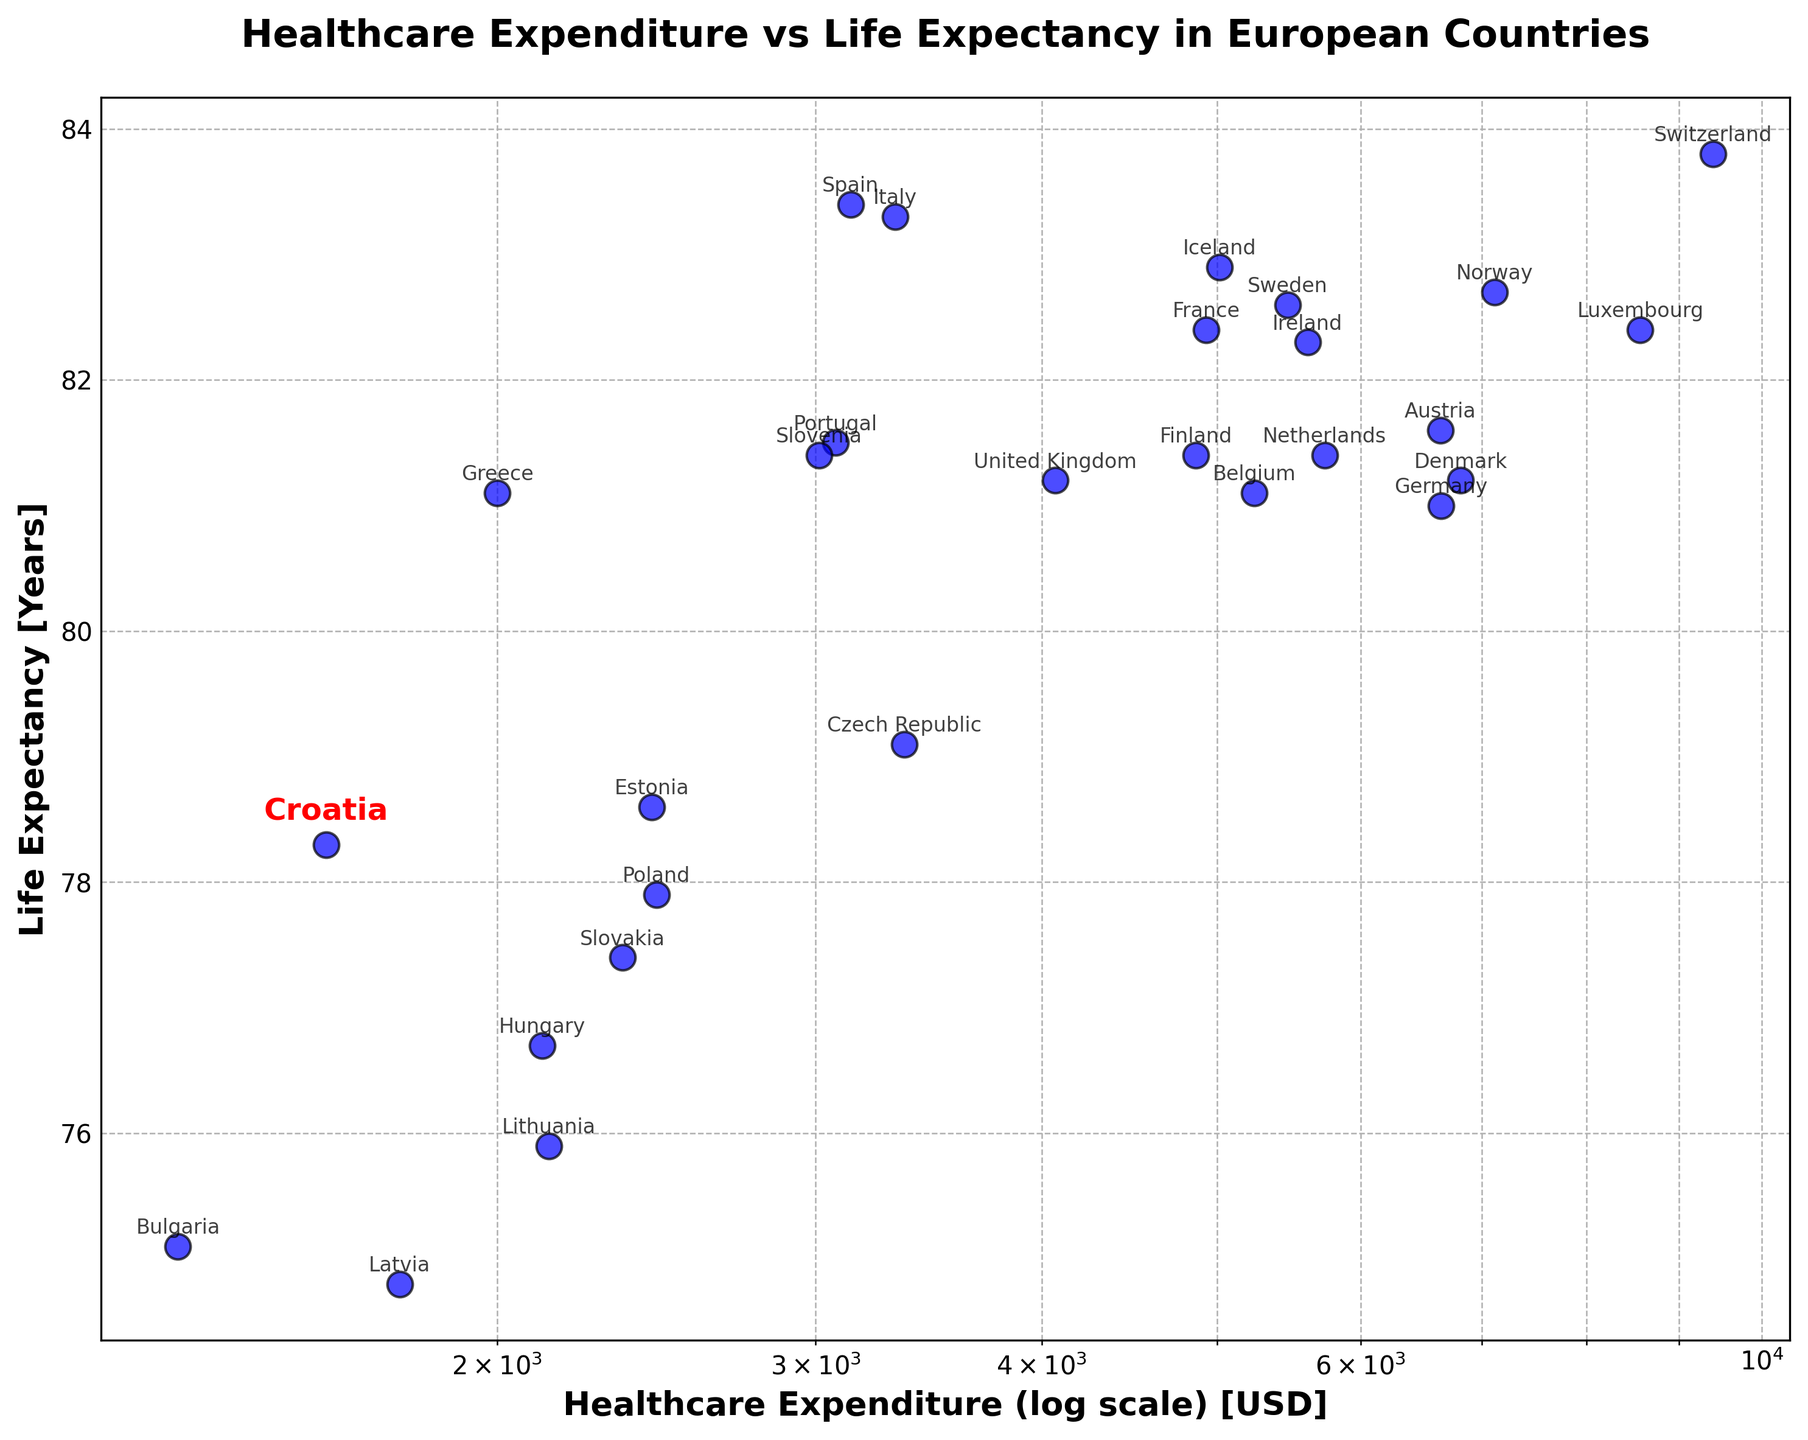What country has the highest healthcare expenditure? The country with the highest healthcare expenditure can be identified by finding the furthest point to the right on the x-axis.
Answer: Switzerland Which country has the lowest life expectancy and what is its healthcare expenditure? Find the lowest point on the y-axis; this country has the lowest life expectancy. The corresponding point on the x-axis will give the healthcare expenditure.
Answer: Bulgaria, $1333 How does Croatia's life expectancy compare to the average life expectancy of all countries in the chart? Calculate the average life expectancy of all countries and compare it to Croatia's life expectancy, 78.3 years.
Answer: Croatia's life expectancy is slightly below average Which country has similar healthcare expenditure as Croatia but has a higher life expectancy? Look for countries near Croatia on the x-axis (around $1609 expenditure) and compare their points on the y-axis.
Answer: Estonia ($2435, 78.6 years) Among the top 5 countries with the highest healthcare expenditure, which one has the highest life expectancy? Identify the top 5 countries on the rightmost side of the x-axis with the highest healthcare expenditure and then find among them which has the highest point on the y-axis.
Answer: Switzerland Is there a general trend between healthcare expenditure and life expectancy in the chart? Observe if there's a pattern where higher healthcare expenditure points align with higher life expectancy points.
Answer: Yes, countries with higher healthcare expenditures tend to have higher life expectancy How do the healthcare expenditure and life expectancy of Croatia compare to the overall median values of the European countries in the chart? Calculate the median healthcare expenditure and life expectancy of all countries and compare these to Croatia's values ($1609 expenditure and 78.3 years).
Answer: Croatia's healthcare expenditure is below median, and life expectancy is close to median Which country has a higher life expectancy: France or Germany? Compare the y-axis positions of the points for France and Germany.
Answer: France What is the difference in life expectancy between the country with the highest and the country with the lowest healthcare expenditure? Find the life expectancy values of the countries with the highest and lowest healthcare expenditure and subtract the lower value from the higher value.
Answer: Around 8.7 years (Switzerland 83.8 years - Bulgaria 75.1 years) Which country has a higher healthcare expenditure, Denmark or Finland, and by how much? Compare the positions of Denmark and Finland on the x-axis and subtract the smaller value from the larger value.
Answer: Denmark; $1949 